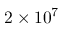Convert formula to latex. <formula><loc_0><loc_0><loc_500><loc_500>2 \times 1 0 ^ { 7 }</formula> 